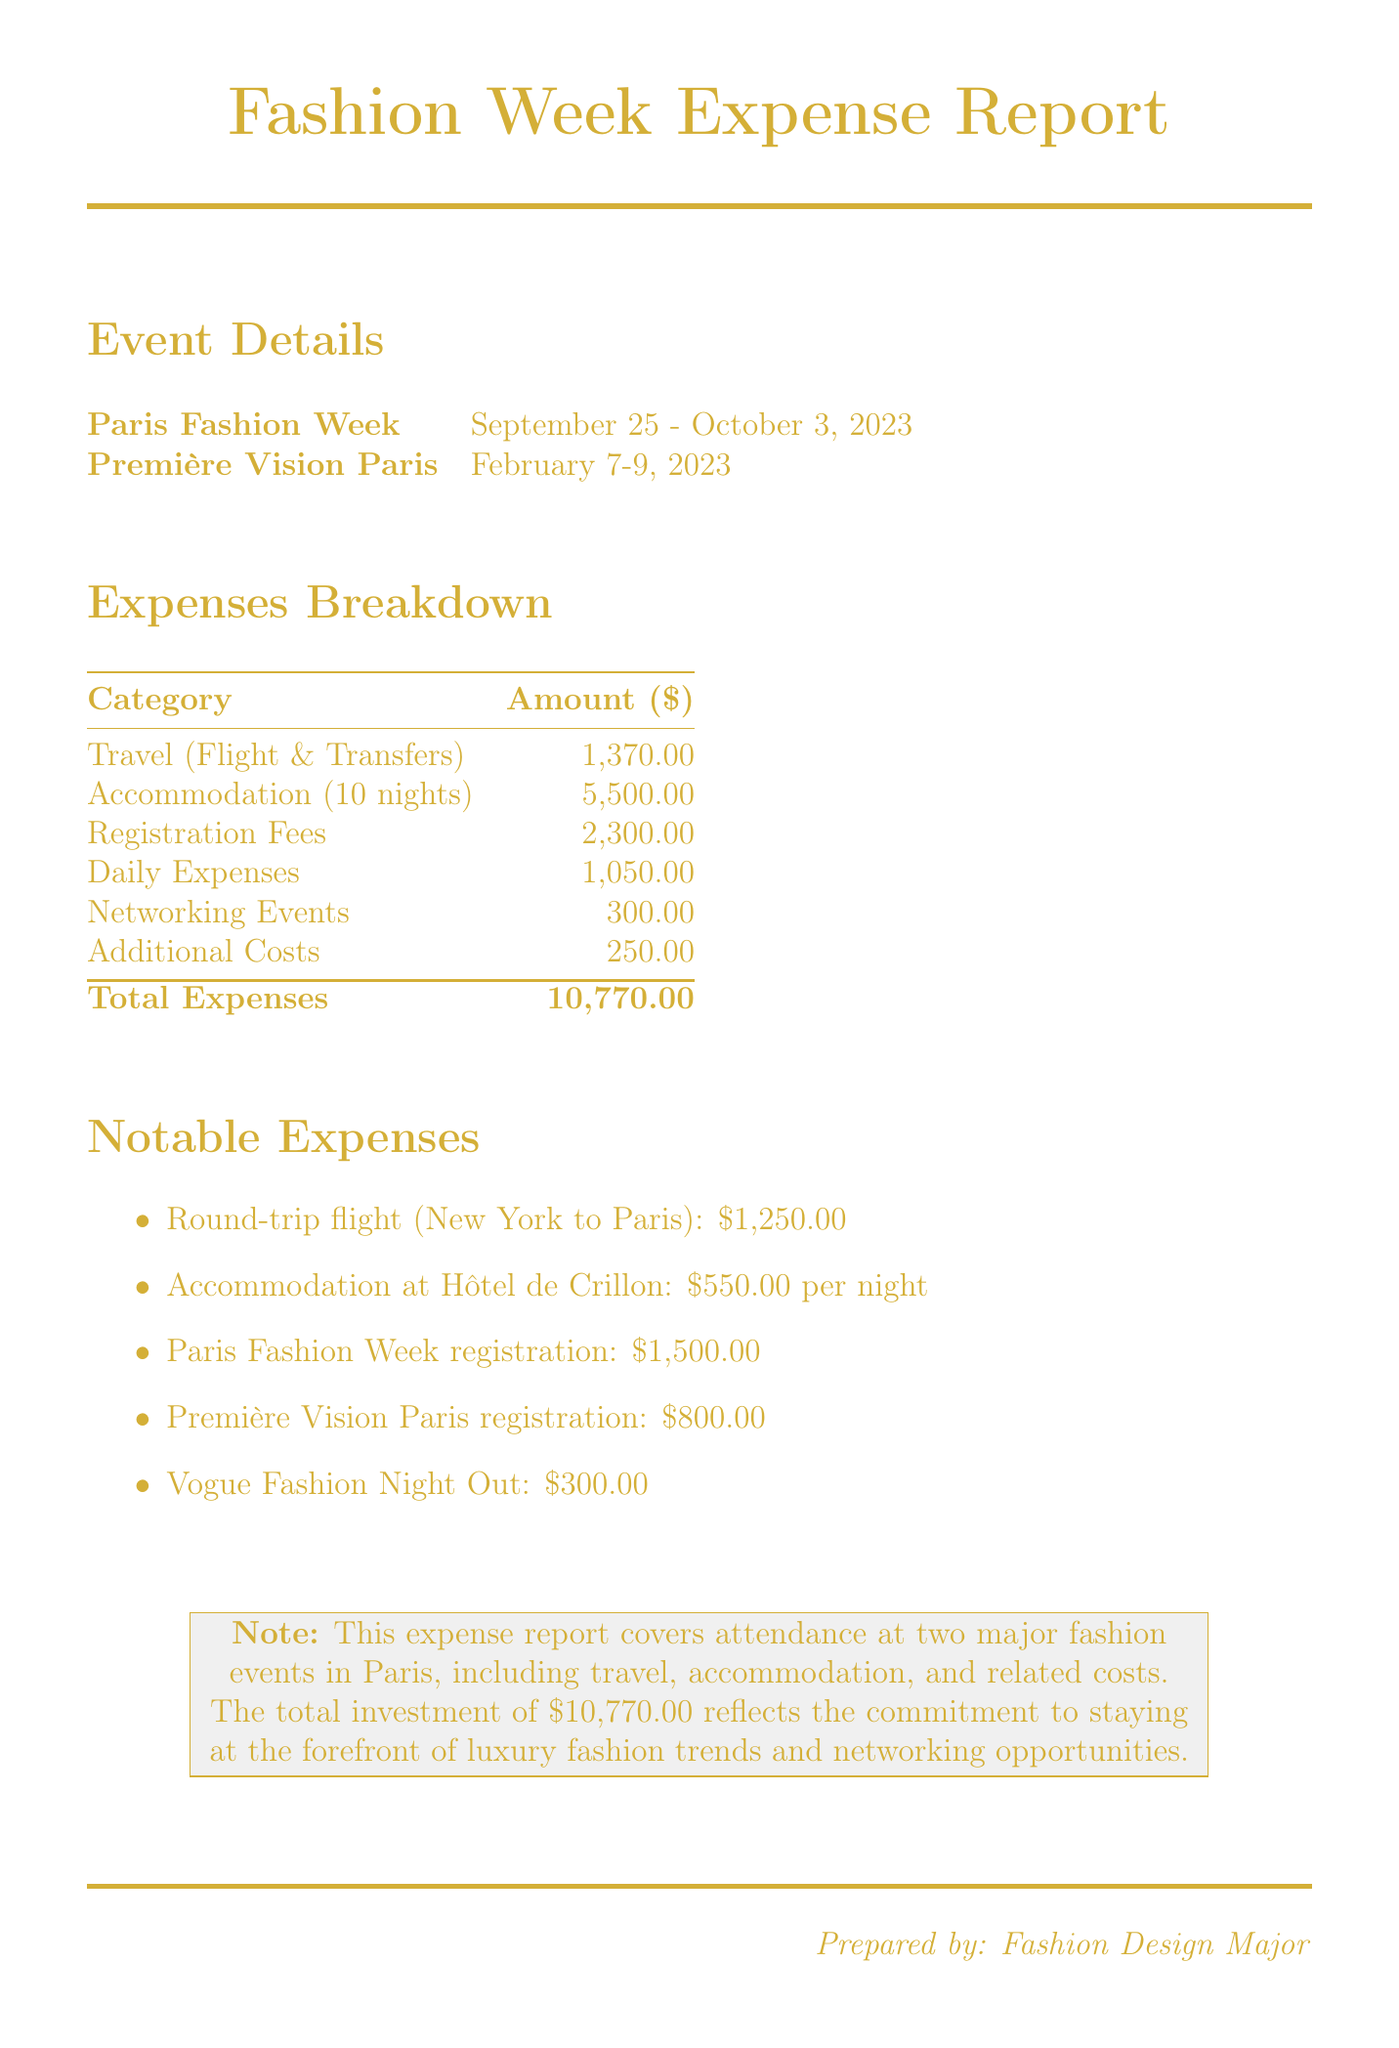What is the total expense for attending international fashion weeks? The total expenses are listed at the bottom of the document, summarizing all costs incurred during the events.
Answer: 10,770.00 How many nights did the accommodation last? The document specifies that the stay was for 10 nights at the hotel.
Answer: 10 What is the registration fee for Paris Fashion Week? The fee for attending Paris Fashion Week is provided in the registration fees section of the document.
Answer: 1,500.00 What airline was used for the round-trip flight? The document mentions Air France as the airline for the round-trip flight between New York and Paris.
Answer: Air France What was the total cost of daily expenses? Daily expenses are itemized in the expenses breakdown section, reflecting the total spent on meals and local transportation.
Answer: 1,050.00 What is the cost of travel insurance? The additional costs section specifies the amount spent on travel insurance.
Answer: 150.00 Where was the accommodation booked? The document indicates that the accommodation was at Hôtel de Crillon, providing the hotel's name and location.
Answer: Hôtel de Crillon What event occurred on February 7-9, 2023? The document lists Première Vision Paris as the event that took place on these dates.
Answer: Première Vision Paris What was the total cost of networking events? The networking events section outlines the expenses incurred, specifically for Vogue Fashion Night Out.
Answer: 300.00 